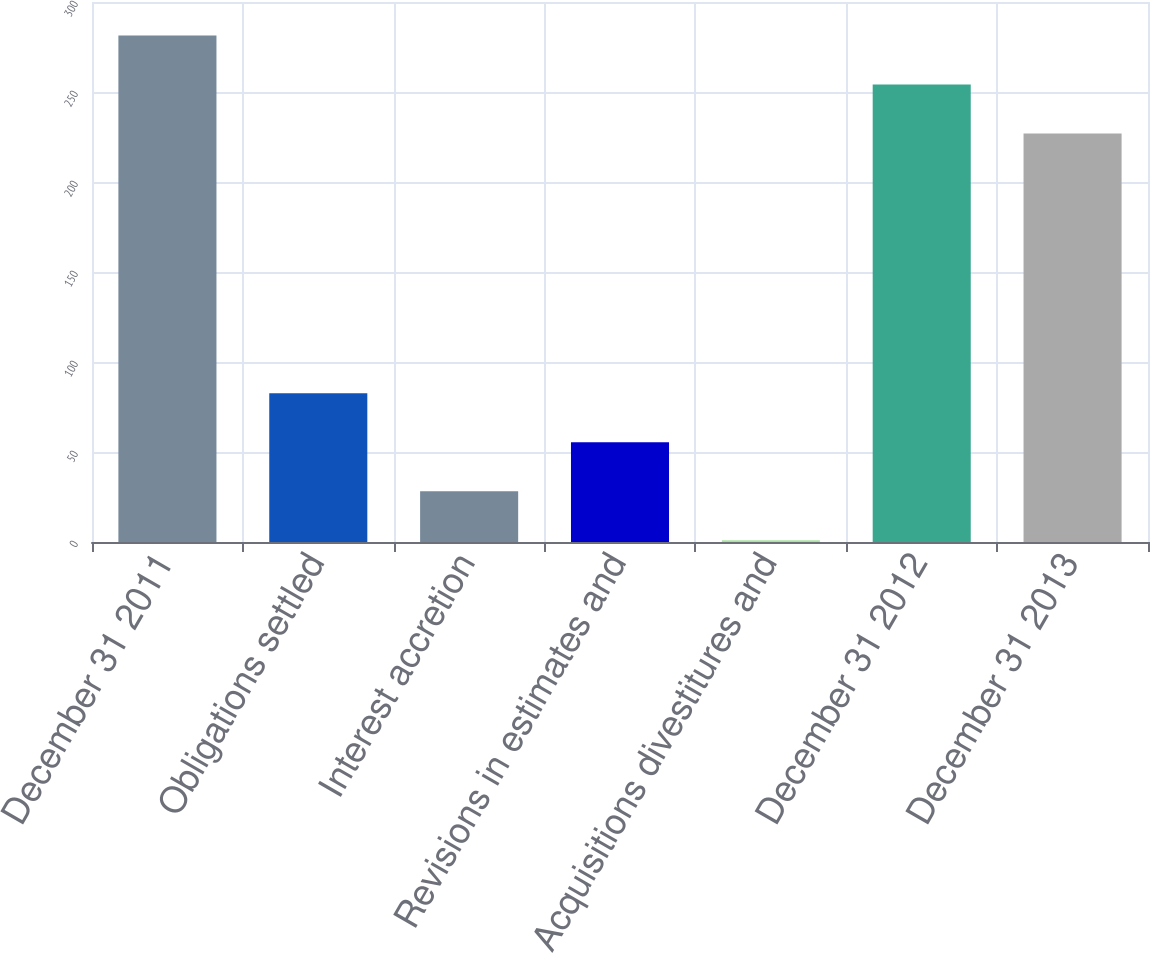<chart> <loc_0><loc_0><loc_500><loc_500><bar_chart><fcel>December 31 2011<fcel>Obligations settled<fcel>Interest accretion<fcel>Revisions in estimates and<fcel>Acquisitions divestitures and<fcel>December 31 2012<fcel>December 31 2013<nl><fcel>281.4<fcel>82.6<fcel>28.2<fcel>55.4<fcel>1<fcel>254.2<fcel>227<nl></chart> 